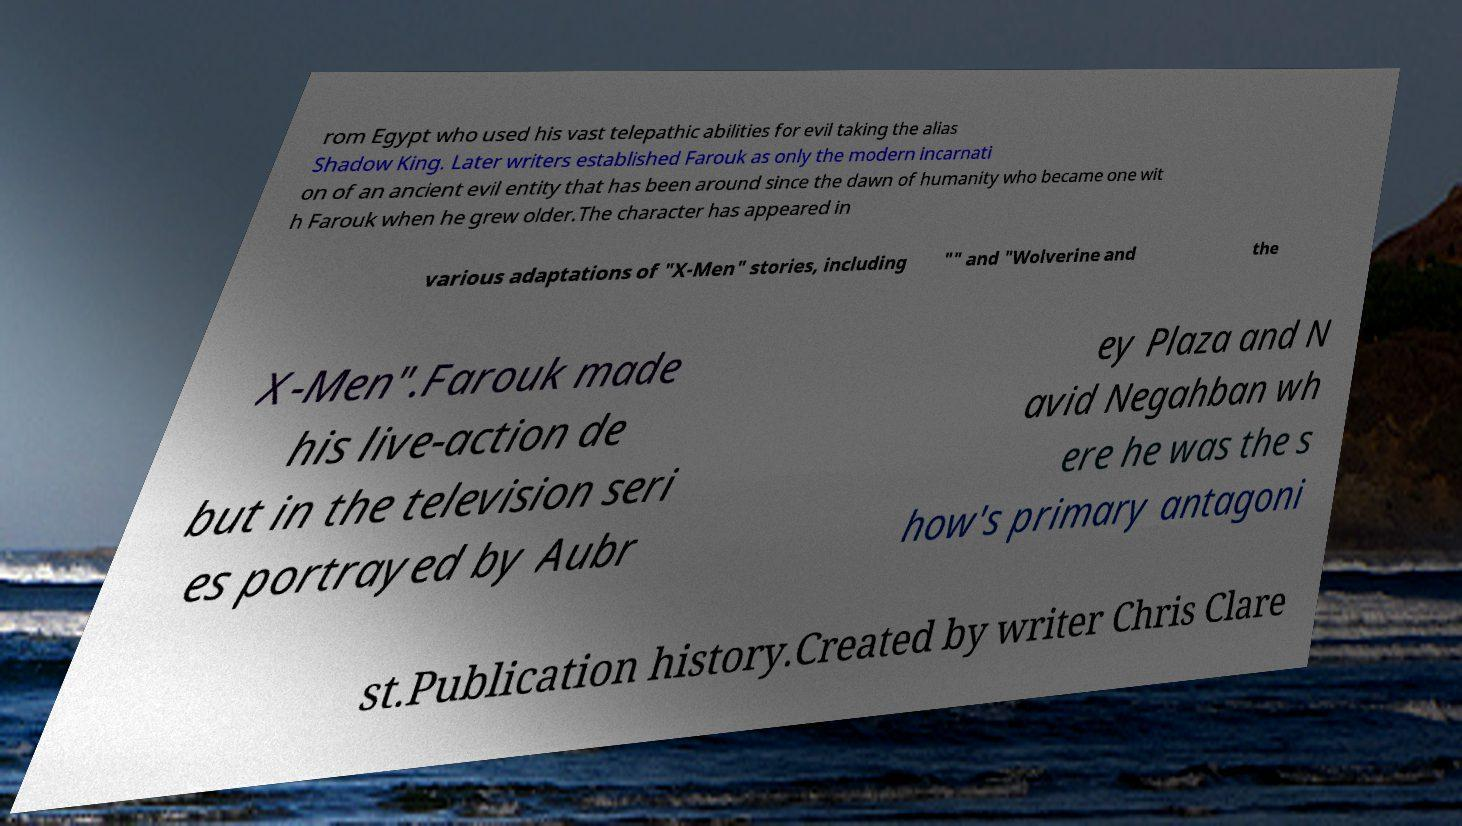There's text embedded in this image that I need extracted. Can you transcribe it verbatim? rom Egypt who used his vast telepathic abilities for evil taking the alias Shadow King. Later writers established Farouk as only the modern incarnati on of an ancient evil entity that has been around since the dawn of humanity who became one wit h Farouk when he grew older.The character has appeared in various adaptations of "X-Men" stories, including "" and "Wolverine and the X-Men".Farouk made his live-action de but in the television seri es portrayed by Aubr ey Plaza and N avid Negahban wh ere he was the s how's primary antagoni st.Publication history.Created by writer Chris Clare 